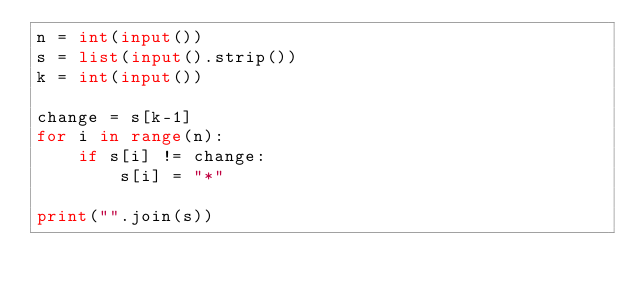<code> <loc_0><loc_0><loc_500><loc_500><_Python_>n = int(input())
s = list(input().strip())
k = int(input())

change = s[k-1]
for i in range(n):
    if s[i] != change:
        s[i] = "*"

print("".join(s))
</code> 